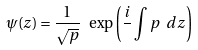<formula> <loc_0><loc_0><loc_500><loc_500>\psi ( z ) = \frac { 1 } { \sqrt { p } } \ \exp { \left ( \frac { i } { } \int { p \ d z } \right ) }</formula> 